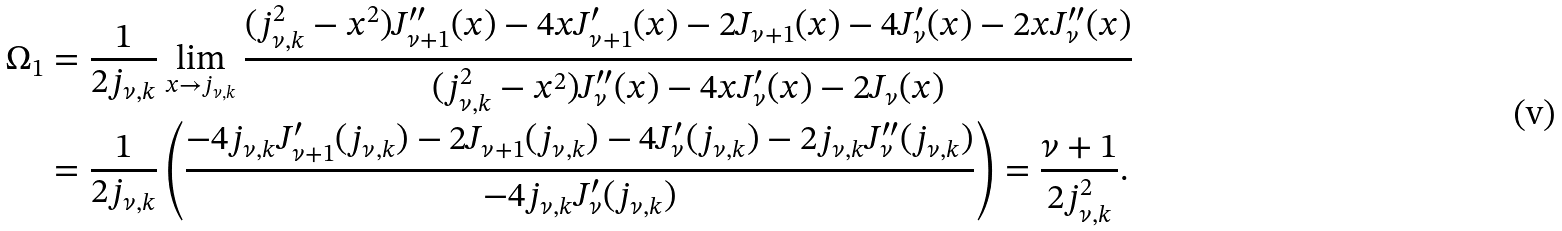Convert formula to latex. <formula><loc_0><loc_0><loc_500><loc_500>\Omega _ { 1 } & = \frac { 1 } { 2 j _ { \nu , k } } \lim _ { x \rightarrow { j _ { \nu , k } } } \frac { ( j _ { \nu , k } ^ { 2 } - x ^ { 2 } ) J _ { \nu + 1 } ^ { \prime \prime } ( x ) - 4 x J _ { \nu + 1 } ^ { \prime } ( x ) - 2 J _ { \nu + 1 } ( x ) - 4 J _ { \nu } ^ { \prime } ( x ) - 2 x J _ { \nu } ^ { \prime \prime } ( x ) } { ( j _ { \nu , k } ^ { 2 } - x ^ { 2 } ) J _ { \nu } ^ { \prime \prime } ( x ) - 4 x J _ { \nu } ^ { \prime } ( x ) - 2 J _ { \nu } ( x ) } \\ & = \frac { 1 } { 2 j _ { \nu , k } } \left ( \frac { - 4 j _ { \nu , k } J _ { \nu + 1 } ^ { \prime } ( j _ { \nu , k } ) - 2 J _ { \nu + 1 } ( j _ { \nu , k } ) - 4 J _ { \nu } ^ { \prime } ( j _ { \nu , k } ) - 2 j _ { \nu , k } J _ { \nu } ^ { \prime \prime } ( j _ { \nu , k } ) } { - 4 j _ { \nu , k } J _ { \nu } ^ { \prime } ( j _ { \nu , k } ) } \right ) = \frac { \nu + 1 } { 2 j _ { \nu , k } ^ { 2 } } .</formula> 